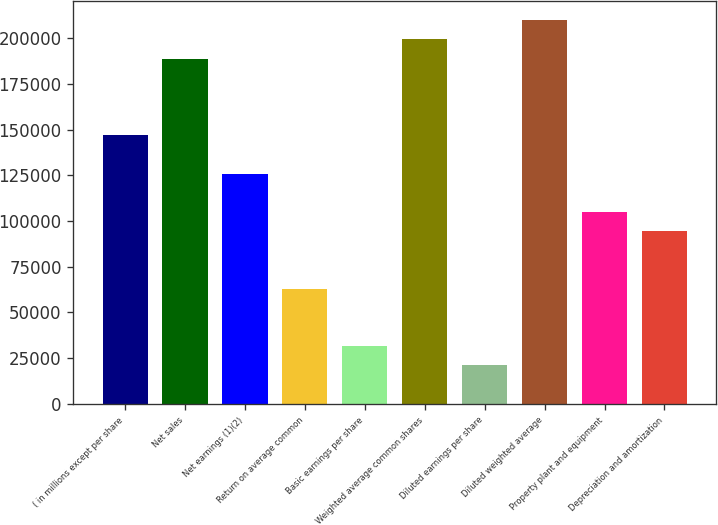Convert chart. <chart><loc_0><loc_0><loc_500><loc_500><bar_chart><fcel>( in millions except per share<fcel>Net sales<fcel>Net earnings (1)(2)<fcel>Return on average common<fcel>Basic earnings per share<fcel>Weighted average common shares<fcel>Diluted earnings per share<fcel>Diluted weighted average<fcel>Property plant and equipment<fcel>Depreciation and amortization<nl><fcel>146931<fcel>188911<fcel>125941<fcel>62970.8<fcel>31485.6<fcel>199407<fcel>20990.5<fcel>209902<fcel>104951<fcel>94455.9<nl></chart> 